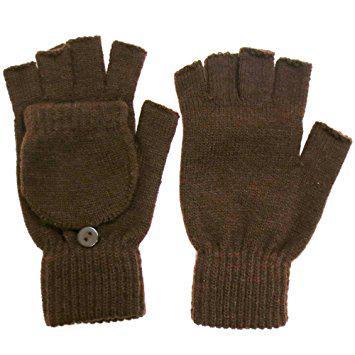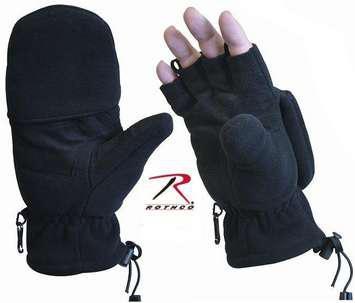The first image is the image on the left, the second image is the image on the right. Examine the images to the left and right. Is the description "In one of the images, human fingers are visible in only one of the two gloves." accurate? Answer yes or no. Yes. 